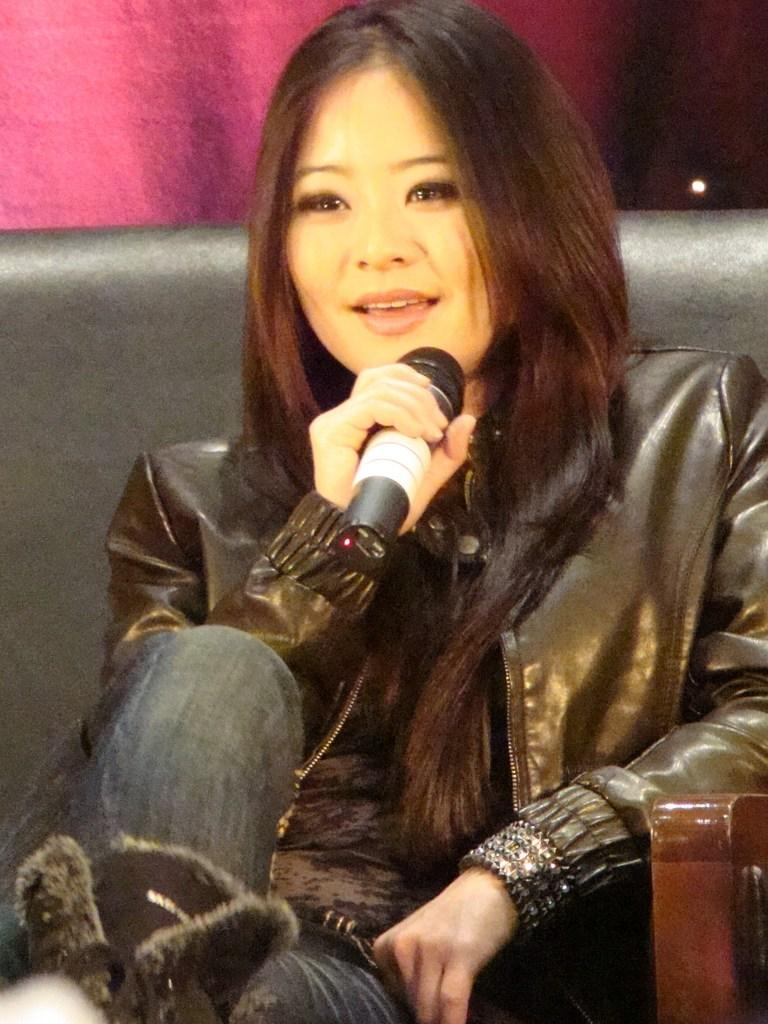Who is present in the image? There is a woman in the image. What is the woman doing in the image? The woman is sitting on a sofa. What is the woman wearing in the image? The woman is wearing a black jacket and jeans. What object is the woman holding in the image? The woman is holding a microphone. What type of arch can be seen in the background of the image? There is no arch visible in the background of the image. What sound does the woman make with the whistle in the image? There is no whistle present in the image. 